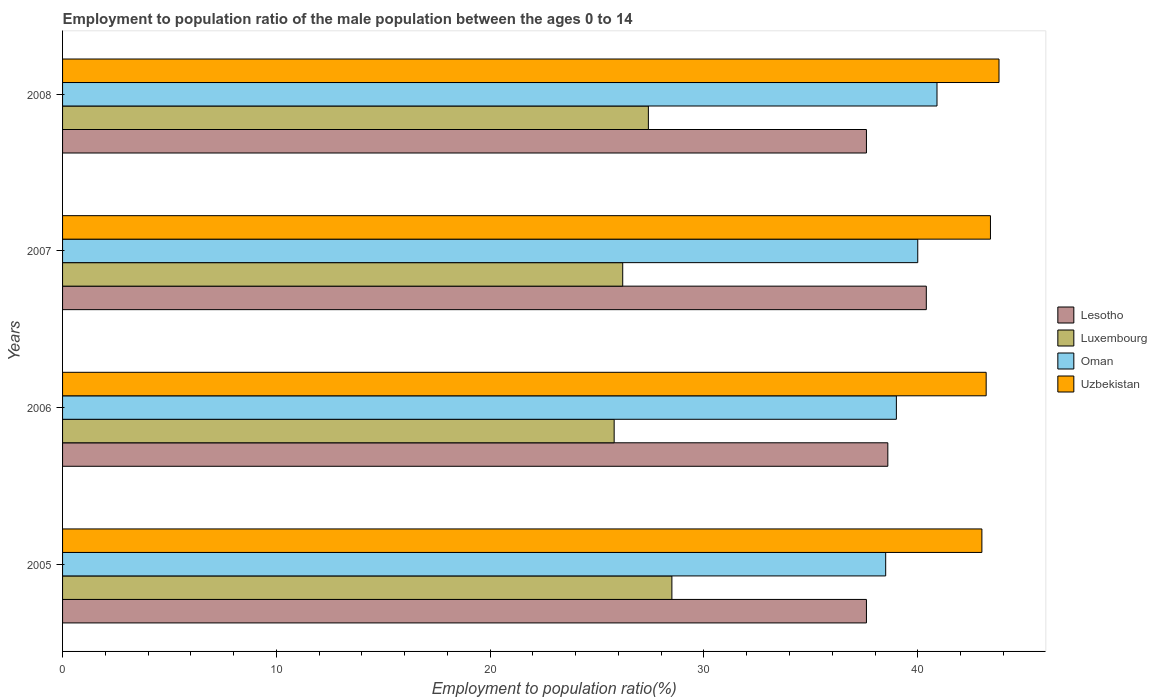How many different coloured bars are there?
Your answer should be compact. 4. How many groups of bars are there?
Provide a short and direct response. 4. Are the number of bars per tick equal to the number of legend labels?
Keep it short and to the point. Yes. How many bars are there on the 3rd tick from the bottom?
Your response must be concise. 4. What is the label of the 3rd group of bars from the top?
Offer a very short reply. 2006. What is the employment to population ratio in Lesotho in 2006?
Your response must be concise. 38.6. Across all years, what is the maximum employment to population ratio in Uzbekistan?
Give a very brief answer. 43.8. Across all years, what is the minimum employment to population ratio in Oman?
Your answer should be compact. 38.5. In which year was the employment to population ratio in Oman maximum?
Provide a short and direct response. 2008. What is the total employment to population ratio in Oman in the graph?
Make the answer very short. 158.4. What is the difference between the employment to population ratio in Luxembourg in 2006 and the employment to population ratio in Lesotho in 2007?
Provide a short and direct response. -14.6. What is the average employment to population ratio in Lesotho per year?
Your answer should be compact. 38.55. In the year 2008, what is the difference between the employment to population ratio in Oman and employment to population ratio in Lesotho?
Provide a short and direct response. 3.3. What is the ratio of the employment to population ratio in Oman in 2005 to that in 2007?
Give a very brief answer. 0.96. Is the difference between the employment to population ratio in Oman in 2007 and 2008 greater than the difference between the employment to population ratio in Lesotho in 2007 and 2008?
Your answer should be compact. No. What is the difference between the highest and the second highest employment to population ratio in Oman?
Provide a succinct answer. 0.9. What is the difference between the highest and the lowest employment to population ratio in Luxembourg?
Your answer should be compact. 2.7. Is the sum of the employment to population ratio in Uzbekistan in 2005 and 2008 greater than the maximum employment to population ratio in Oman across all years?
Keep it short and to the point. Yes. Is it the case that in every year, the sum of the employment to population ratio in Oman and employment to population ratio in Lesotho is greater than the sum of employment to population ratio in Luxembourg and employment to population ratio in Uzbekistan?
Provide a short and direct response. No. What does the 3rd bar from the top in 2008 represents?
Provide a succinct answer. Luxembourg. What does the 2nd bar from the bottom in 2007 represents?
Offer a terse response. Luxembourg. Are all the bars in the graph horizontal?
Offer a terse response. Yes. Does the graph contain any zero values?
Provide a short and direct response. No. Does the graph contain grids?
Make the answer very short. No. Where does the legend appear in the graph?
Give a very brief answer. Center right. How many legend labels are there?
Make the answer very short. 4. What is the title of the graph?
Your response must be concise. Employment to population ratio of the male population between the ages 0 to 14. What is the label or title of the X-axis?
Your response must be concise. Employment to population ratio(%). What is the Employment to population ratio(%) in Lesotho in 2005?
Ensure brevity in your answer.  37.6. What is the Employment to population ratio(%) in Luxembourg in 2005?
Make the answer very short. 28.5. What is the Employment to population ratio(%) in Oman in 2005?
Provide a succinct answer. 38.5. What is the Employment to population ratio(%) of Uzbekistan in 2005?
Offer a terse response. 43. What is the Employment to population ratio(%) of Lesotho in 2006?
Keep it short and to the point. 38.6. What is the Employment to population ratio(%) of Luxembourg in 2006?
Keep it short and to the point. 25.8. What is the Employment to population ratio(%) in Uzbekistan in 2006?
Keep it short and to the point. 43.2. What is the Employment to population ratio(%) in Lesotho in 2007?
Make the answer very short. 40.4. What is the Employment to population ratio(%) of Luxembourg in 2007?
Your answer should be very brief. 26.2. What is the Employment to population ratio(%) of Uzbekistan in 2007?
Ensure brevity in your answer.  43.4. What is the Employment to population ratio(%) of Lesotho in 2008?
Ensure brevity in your answer.  37.6. What is the Employment to population ratio(%) in Luxembourg in 2008?
Ensure brevity in your answer.  27.4. What is the Employment to population ratio(%) of Oman in 2008?
Keep it short and to the point. 40.9. What is the Employment to population ratio(%) of Uzbekistan in 2008?
Provide a short and direct response. 43.8. Across all years, what is the maximum Employment to population ratio(%) in Lesotho?
Your answer should be very brief. 40.4. Across all years, what is the maximum Employment to population ratio(%) of Oman?
Make the answer very short. 40.9. Across all years, what is the maximum Employment to population ratio(%) of Uzbekistan?
Make the answer very short. 43.8. Across all years, what is the minimum Employment to population ratio(%) of Lesotho?
Make the answer very short. 37.6. Across all years, what is the minimum Employment to population ratio(%) of Luxembourg?
Provide a succinct answer. 25.8. Across all years, what is the minimum Employment to population ratio(%) of Oman?
Ensure brevity in your answer.  38.5. Across all years, what is the minimum Employment to population ratio(%) of Uzbekistan?
Ensure brevity in your answer.  43. What is the total Employment to population ratio(%) in Lesotho in the graph?
Make the answer very short. 154.2. What is the total Employment to population ratio(%) in Luxembourg in the graph?
Ensure brevity in your answer.  107.9. What is the total Employment to population ratio(%) of Oman in the graph?
Make the answer very short. 158.4. What is the total Employment to population ratio(%) in Uzbekistan in the graph?
Keep it short and to the point. 173.4. What is the difference between the Employment to population ratio(%) of Oman in 2005 and that in 2006?
Your answer should be compact. -0.5. What is the difference between the Employment to population ratio(%) in Oman in 2005 and that in 2007?
Offer a very short reply. -1.5. What is the difference between the Employment to population ratio(%) of Lesotho in 2006 and that in 2007?
Offer a terse response. -1.8. What is the difference between the Employment to population ratio(%) in Luxembourg in 2006 and that in 2007?
Make the answer very short. -0.4. What is the difference between the Employment to population ratio(%) of Uzbekistan in 2006 and that in 2007?
Provide a short and direct response. -0.2. What is the difference between the Employment to population ratio(%) in Luxembourg in 2006 and that in 2008?
Provide a succinct answer. -1.6. What is the difference between the Employment to population ratio(%) of Oman in 2006 and that in 2008?
Offer a terse response. -1.9. What is the difference between the Employment to population ratio(%) in Uzbekistan in 2006 and that in 2008?
Your answer should be compact. -0.6. What is the difference between the Employment to population ratio(%) in Luxembourg in 2007 and that in 2008?
Offer a terse response. -1.2. What is the difference between the Employment to population ratio(%) in Uzbekistan in 2007 and that in 2008?
Offer a very short reply. -0.4. What is the difference between the Employment to population ratio(%) in Lesotho in 2005 and the Employment to population ratio(%) in Luxembourg in 2006?
Your answer should be very brief. 11.8. What is the difference between the Employment to population ratio(%) in Lesotho in 2005 and the Employment to population ratio(%) in Uzbekistan in 2006?
Your answer should be very brief. -5.6. What is the difference between the Employment to population ratio(%) in Luxembourg in 2005 and the Employment to population ratio(%) in Oman in 2006?
Make the answer very short. -10.5. What is the difference between the Employment to population ratio(%) of Luxembourg in 2005 and the Employment to population ratio(%) of Uzbekistan in 2006?
Ensure brevity in your answer.  -14.7. What is the difference between the Employment to population ratio(%) in Lesotho in 2005 and the Employment to population ratio(%) in Luxembourg in 2007?
Offer a terse response. 11.4. What is the difference between the Employment to population ratio(%) in Lesotho in 2005 and the Employment to population ratio(%) in Uzbekistan in 2007?
Make the answer very short. -5.8. What is the difference between the Employment to population ratio(%) of Luxembourg in 2005 and the Employment to population ratio(%) of Oman in 2007?
Provide a short and direct response. -11.5. What is the difference between the Employment to population ratio(%) of Luxembourg in 2005 and the Employment to population ratio(%) of Uzbekistan in 2007?
Keep it short and to the point. -14.9. What is the difference between the Employment to population ratio(%) of Oman in 2005 and the Employment to population ratio(%) of Uzbekistan in 2007?
Make the answer very short. -4.9. What is the difference between the Employment to population ratio(%) of Lesotho in 2005 and the Employment to population ratio(%) of Oman in 2008?
Make the answer very short. -3.3. What is the difference between the Employment to population ratio(%) in Lesotho in 2005 and the Employment to population ratio(%) in Uzbekistan in 2008?
Provide a short and direct response. -6.2. What is the difference between the Employment to population ratio(%) of Luxembourg in 2005 and the Employment to population ratio(%) of Oman in 2008?
Your answer should be compact. -12.4. What is the difference between the Employment to population ratio(%) of Luxembourg in 2005 and the Employment to population ratio(%) of Uzbekistan in 2008?
Keep it short and to the point. -15.3. What is the difference between the Employment to population ratio(%) in Oman in 2005 and the Employment to population ratio(%) in Uzbekistan in 2008?
Give a very brief answer. -5.3. What is the difference between the Employment to population ratio(%) of Lesotho in 2006 and the Employment to population ratio(%) of Luxembourg in 2007?
Provide a succinct answer. 12.4. What is the difference between the Employment to population ratio(%) of Lesotho in 2006 and the Employment to population ratio(%) of Uzbekistan in 2007?
Make the answer very short. -4.8. What is the difference between the Employment to population ratio(%) of Luxembourg in 2006 and the Employment to population ratio(%) of Uzbekistan in 2007?
Keep it short and to the point. -17.6. What is the difference between the Employment to population ratio(%) of Oman in 2006 and the Employment to population ratio(%) of Uzbekistan in 2007?
Make the answer very short. -4.4. What is the difference between the Employment to population ratio(%) in Lesotho in 2006 and the Employment to population ratio(%) in Luxembourg in 2008?
Make the answer very short. 11.2. What is the difference between the Employment to population ratio(%) in Lesotho in 2006 and the Employment to population ratio(%) in Uzbekistan in 2008?
Offer a terse response. -5.2. What is the difference between the Employment to population ratio(%) of Luxembourg in 2006 and the Employment to population ratio(%) of Oman in 2008?
Ensure brevity in your answer.  -15.1. What is the difference between the Employment to population ratio(%) in Lesotho in 2007 and the Employment to population ratio(%) in Luxembourg in 2008?
Offer a terse response. 13. What is the difference between the Employment to population ratio(%) in Lesotho in 2007 and the Employment to population ratio(%) in Uzbekistan in 2008?
Provide a short and direct response. -3.4. What is the difference between the Employment to population ratio(%) in Luxembourg in 2007 and the Employment to population ratio(%) in Oman in 2008?
Offer a very short reply. -14.7. What is the difference between the Employment to population ratio(%) of Luxembourg in 2007 and the Employment to population ratio(%) of Uzbekistan in 2008?
Your response must be concise. -17.6. What is the difference between the Employment to population ratio(%) of Oman in 2007 and the Employment to population ratio(%) of Uzbekistan in 2008?
Provide a succinct answer. -3.8. What is the average Employment to population ratio(%) in Lesotho per year?
Your answer should be compact. 38.55. What is the average Employment to population ratio(%) in Luxembourg per year?
Your response must be concise. 26.98. What is the average Employment to population ratio(%) in Oman per year?
Your answer should be very brief. 39.6. What is the average Employment to population ratio(%) in Uzbekistan per year?
Make the answer very short. 43.35. In the year 2005, what is the difference between the Employment to population ratio(%) in Luxembourg and Employment to population ratio(%) in Oman?
Offer a terse response. -10. In the year 2005, what is the difference between the Employment to population ratio(%) in Oman and Employment to population ratio(%) in Uzbekistan?
Make the answer very short. -4.5. In the year 2006, what is the difference between the Employment to population ratio(%) of Lesotho and Employment to population ratio(%) of Luxembourg?
Provide a short and direct response. 12.8. In the year 2006, what is the difference between the Employment to population ratio(%) in Lesotho and Employment to population ratio(%) in Oman?
Your answer should be compact. -0.4. In the year 2006, what is the difference between the Employment to population ratio(%) of Luxembourg and Employment to population ratio(%) of Uzbekistan?
Offer a terse response. -17.4. In the year 2007, what is the difference between the Employment to population ratio(%) in Lesotho and Employment to population ratio(%) in Uzbekistan?
Keep it short and to the point. -3. In the year 2007, what is the difference between the Employment to population ratio(%) of Luxembourg and Employment to population ratio(%) of Oman?
Offer a very short reply. -13.8. In the year 2007, what is the difference between the Employment to population ratio(%) of Luxembourg and Employment to population ratio(%) of Uzbekistan?
Provide a short and direct response. -17.2. In the year 2008, what is the difference between the Employment to population ratio(%) in Lesotho and Employment to population ratio(%) in Luxembourg?
Offer a terse response. 10.2. In the year 2008, what is the difference between the Employment to population ratio(%) in Lesotho and Employment to population ratio(%) in Oman?
Give a very brief answer. -3.3. In the year 2008, what is the difference between the Employment to population ratio(%) in Luxembourg and Employment to population ratio(%) in Oman?
Offer a terse response. -13.5. In the year 2008, what is the difference between the Employment to population ratio(%) of Luxembourg and Employment to population ratio(%) of Uzbekistan?
Your response must be concise. -16.4. What is the ratio of the Employment to population ratio(%) of Lesotho in 2005 to that in 2006?
Your answer should be very brief. 0.97. What is the ratio of the Employment to population ratio(%) in Luxembourg in 2005 to that in 2006?
Your answer should be very brief. 1.1. What is the ratio of the Employment to population ratio(%) of Oman in 2005 to that in 2006?
Provide a succinct answer. 0.99. What is the ratio of the Employment to population ratio(%) of Lesotho in 2005 to that in 2007?
Offer a very short reply. 0.93. What is the ratio of the Employment to population ratio(%) in Luxembourg in 2005 to that in 2007?
Make the answer very short. 1.09. What is the ratio of the Employment to population ratio(%) of Oman in 2005 to that in 2007?
Provide a succinct answer. 0.96. What is the ratio of the Employment to population ratio(%) of Uzbekistan in 2005 to that in 2007?
Your response must be concise. 0.99. What is the ratio of the Employment to population ratio(%) of Lesotho in 2005 to that in 2008?
Your response must be concise. 1. What is the ratio of the Employment to population ratio(%) of Luxembourg in 2005 to that in 2008?
Offer a very short reply. 1.04. What is the ratio of the Employment to population ratio(%) of Oman in 2005 to that in 2008?
Your answer should be very brief. 0.94. What is the ratio of the Employment to population ratio(%) of Uzbekistan in 2005 to that in 2008?
Provide a succinct answer. 0.98. What is the ratio of the Employment to population ratio(%) of Lesotho in 2006 to that in 2007?
Offer a terse response. 0.96. What is the ratio of the Employment to population ratio(%) in Luxembourg in 2006 to that in 2007?
Give a very brief answer. 0.98. What is the ratio of the Employment to population ratio(%) of Oman in 2006 to that in 2007?
Ensure brevity in your answer.  0.97. What is the ratio of the Employment to population ratio(%) in Lesotho in 2006 to that in 2008?
Offer a very short reply. 1.03. What is the ratio of the Employment to population ratio(%) in Luxembourg in 2006 to that in 2008?
Keep it short and to the point. 0.94. What is the ratio of the Employment to population ratio(%) in Oman in 2006 to that in 2008?
Ensure brevity in your answer.  0.95. What is the ratio of the Employment to population ratio(%) in Uzbekistan in 2006 to that in 2008?
Ensure brevity in your answer.  0.99. What is the ratio of the Employment to population ratio(%) of Lesotho in 2007 to that in 2008?
Your answer should be very brief. 1.07. What is the ratio of the Employment to population ratio(%) in Luxembourg in 2007 to that in 2008?
Provide a short and direct response. 0.96. What is the ratio of the Employment to population ratio(%) of Uzbekistan in 2007 to that in 2008?
Offer a terse response. 0.99. What is the difference between the highest and the second highest Employment to population ratio(%) in Oman?
Your response must be concise. 0.9. What is the difference between the highest and the lowest Employment to population ratio(%) in Oman?
Your answer should be compact. 2.4. 